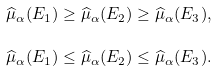Convert formula to latex. <formula><loc_0><loc_0><loc_500><loc_500>\widehat { \mu } _ { \alpha } ( E _ { 1 } ) \geq \widehat { \mu } _ { \alpha } ( E _ { 2 } ) \geq \widehat { \mu } _ { \alpha } ( E _ { 3 } ) , \\ \widehat { \mu } _ { \alpha } ( E _ { 1 } ) \leq \widehat { \mu } _ { \alpha } ( E _ { 2 } ) \leq \widehat { \mu } _ { \alpha } ( E _ { 3 } ) .</formula> 